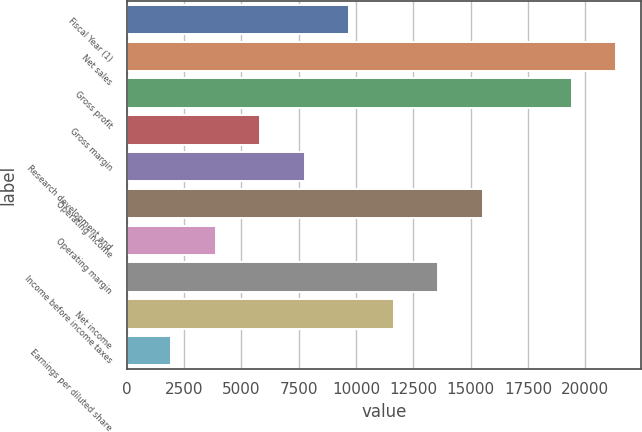<chart> <loc_0><loc_0><loc_500><loc_500><bar_chart><fcel>Fiscal Year (1)<fcel>Net sales<fcel>Gross profit<fcel>Gross margin<fcel>Research development and<fcel>Operating income<fcel>Operating margin<fcel>Income before income taxes<fcel>Net income<fcel>Earnings per diluted share<nl><fcel>9709.7<fcel>21360.9<fcel>19419<fcel>5825.98<fcel>7767.84<fcel>15535.3<fcel>3884.12<fcel>13593.4<fcel>11651.6<fcel>1942.26<nl></chart> 